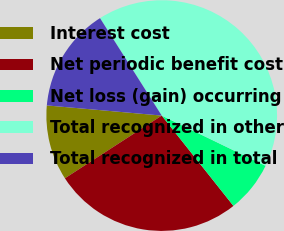Convert chart to OTSL. <chart><loc_0><loc_0><loc_500><loc_500><pie_chart><fcel>Interest cost<fcel>Net periodic benefit cost<fcel>Net loss (gain) occurring<fcel>Total recognized in other<fcel>Total recognized in total<nl><fcel>10.55%<fcel>26.53%<fcel>7.15%<fcel>41.15%<fcel>14.61%<nl></chart> 